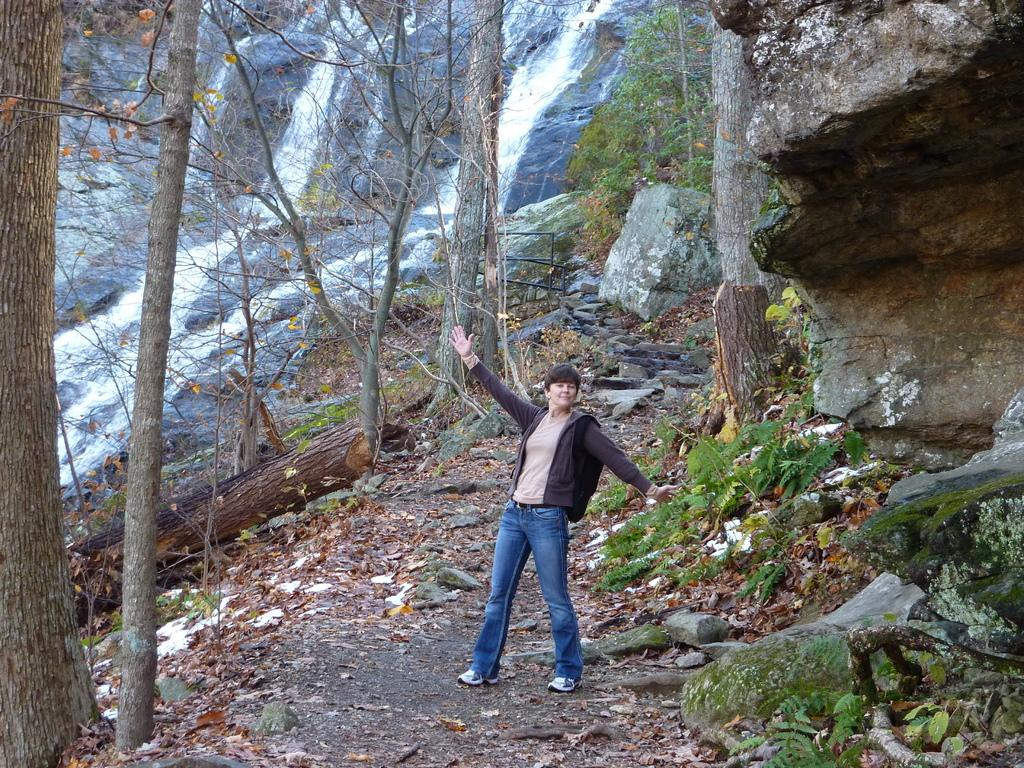What is the main subject of the image? There is a person standing in the image. What can be seen around the person? There are rocks around the person. What type of natural environment is depicted in the image? There are trees and a waterfall in the image. What type of vase can be seen in the image? There is no vase present in the image. Can you describe the space station in the image? There is no space station present in the image; it is set in a natural environment with trees and a waterfall. 